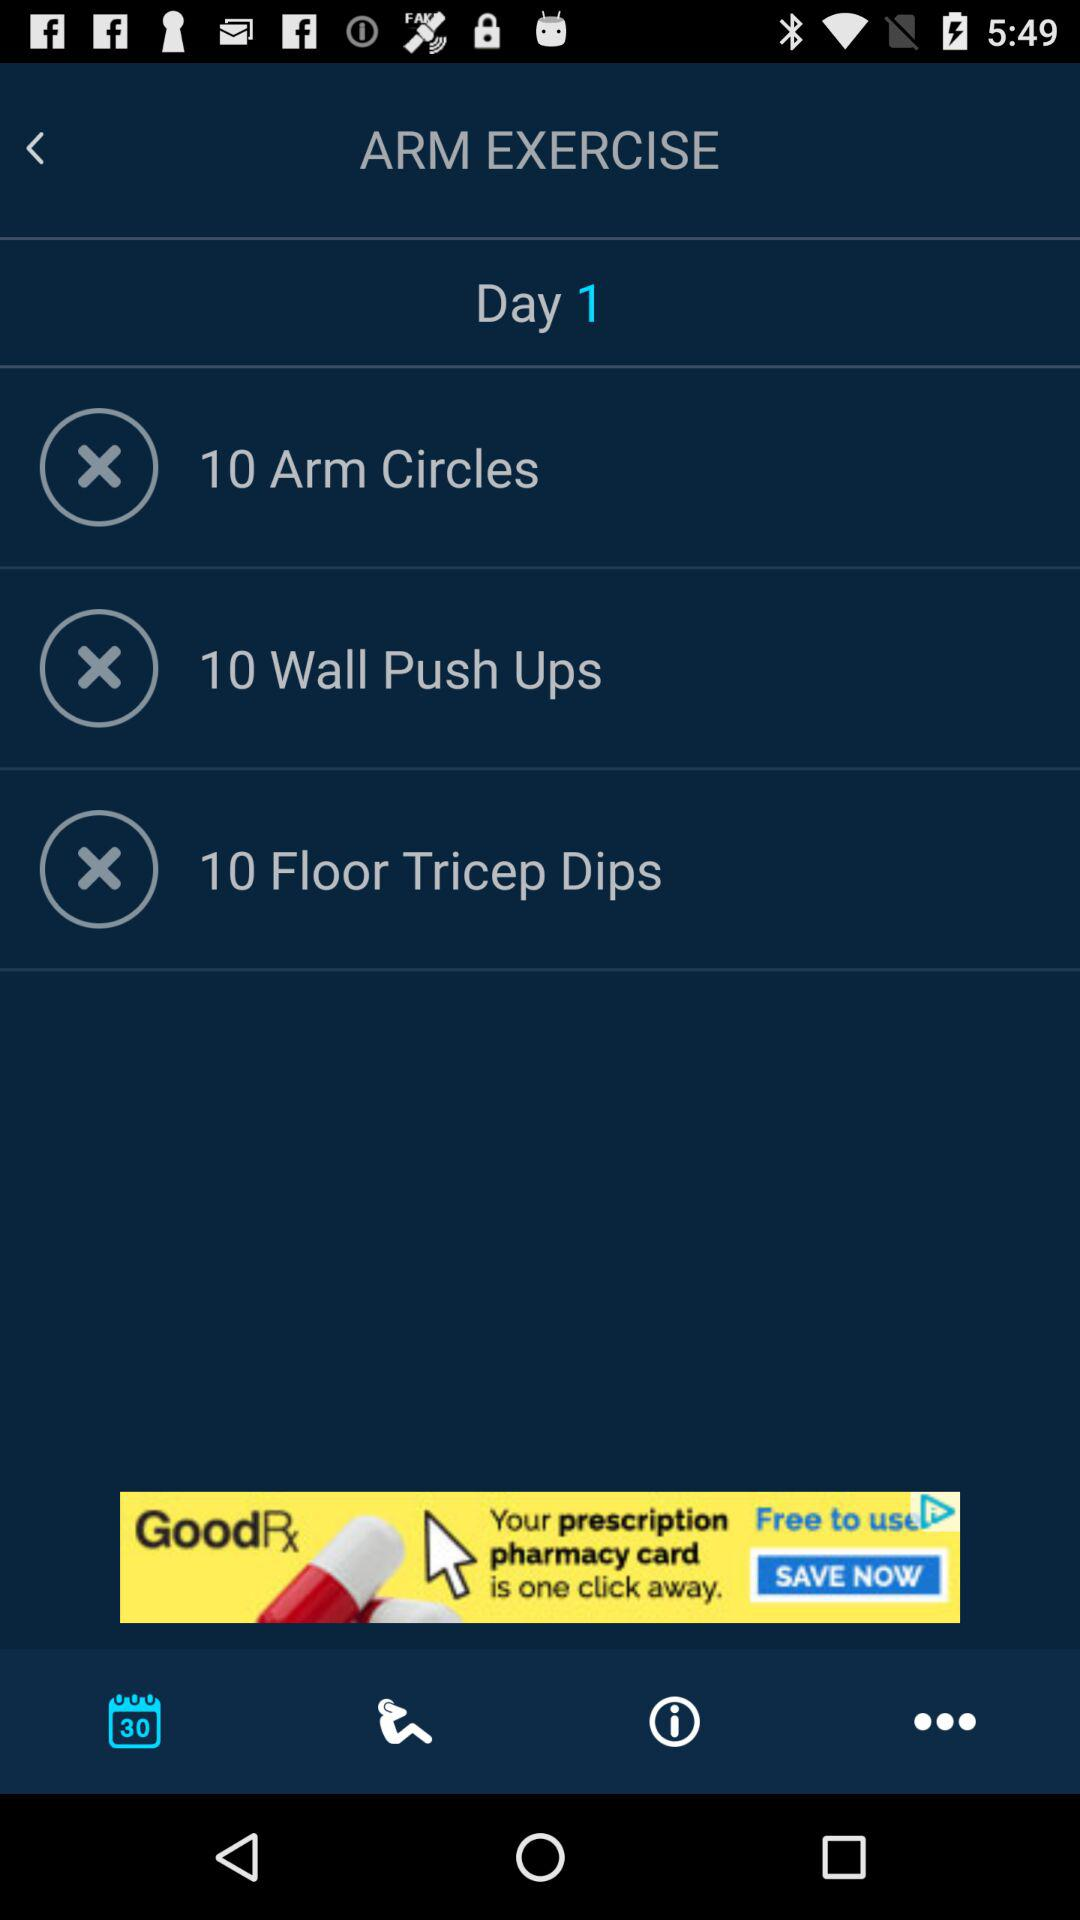What exercises are to be performed on day 1? The exercises are "10 Arm Circles", "10 Wall Push Ups" and "10 Floor Tricep Dips". 